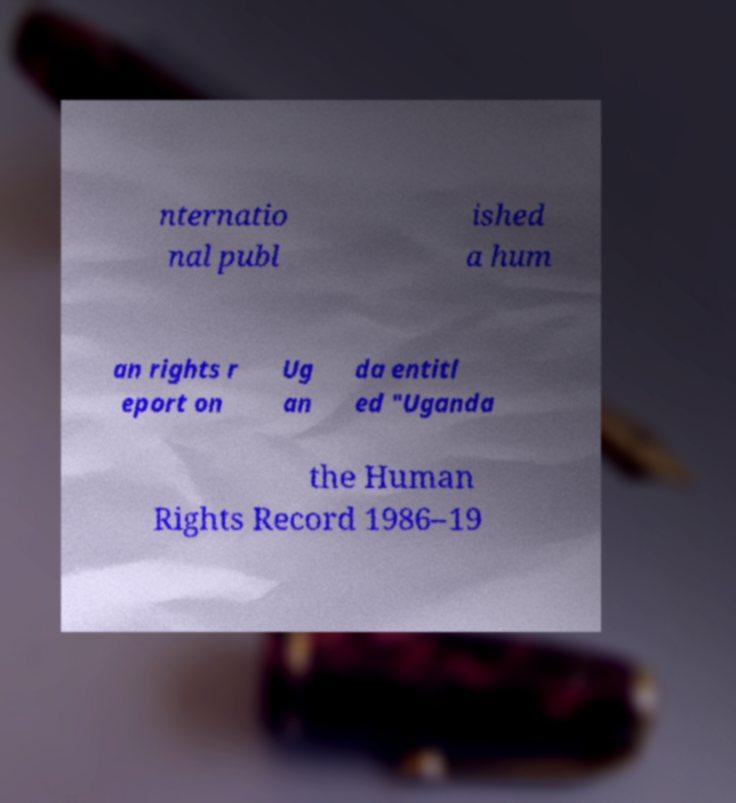Please read and relay the text visible in this image. What does it say? nternatio nal publ ished a hum an rights r eport on Ug an da entitl ed "Uganda the Human Rights Record 1986–19 